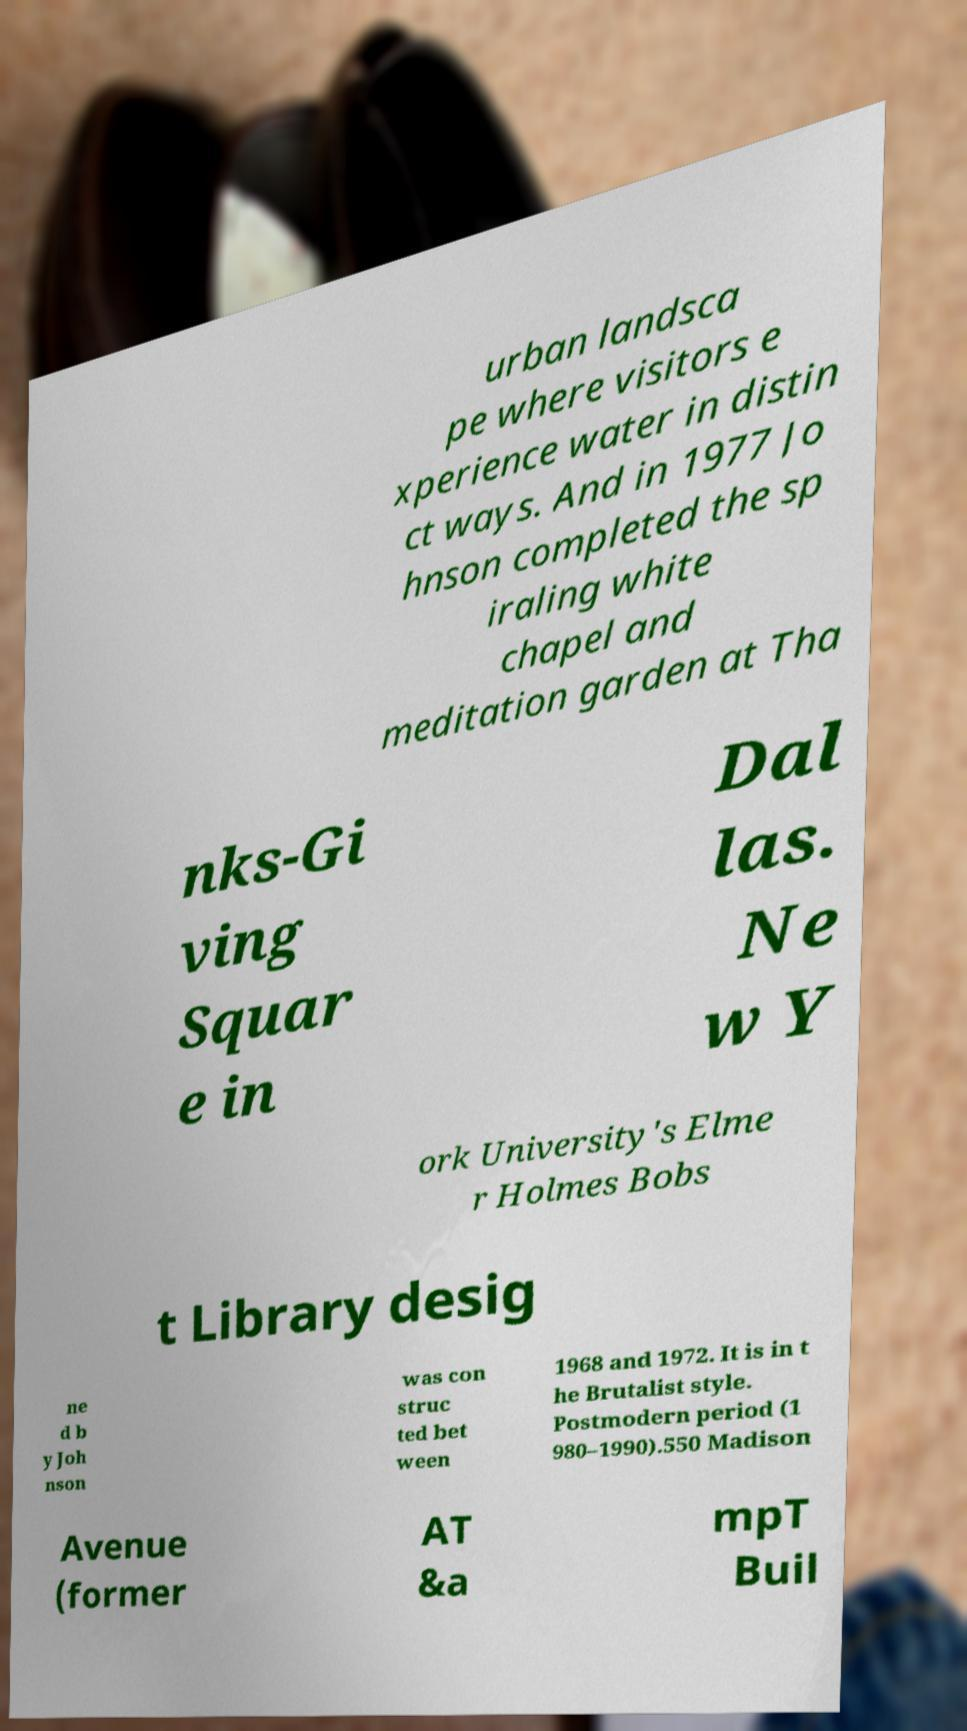I need the written content from this picture converted into text. Can you do that? urban landsca pe where visitors e xperience water in distin ct ways. And in 1977 Jo hnson completed the sp iraling white chapel and meditation garden at Tha nks-Gi ving Squar e in Dal las. Ne w Y ork University's Elme r Holmes Bobs t Library desig ne d b y Joh nson was con struc ted bet ween 1968 and 1972. It is in t he Brutalist style. Postmodern period (1 980–1990).550 Madison Avenue (former AT &a mpT Buil 